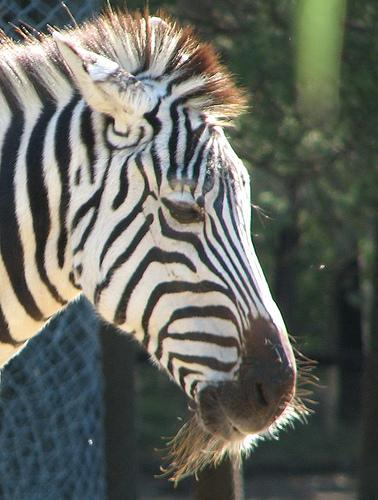What item is present in the background behind the zebra, and how detailed is it? There is a chain fence behind the zebra, but it's barely visible due to the limited coverage in the image. Elaborate on the zebra's neck detail and the orientation of its stripes. The zebra's neck has wide black and white stripes that are vertical on the front part, and the mane is sticking straight up. Discuss one particular feature related to the zebra's head and explain it in detail. The zebra has ears that are back on its head, which can suggest attentiveness or a relaxed state. What is the dominant pattern on the zebra's body and how is its mane oriented? The dominant pattern is black and white stripes, and the mane is sticking straight up. How would you describe the overall appearance of the zebra in the image, including its colors and features? The zebra has a striking appearance with its black and white striped pattern, brown nose, upright mane, and various facial features such as large nostrils, long eyelashes, and whiskers. Determine the color of zebra's nose and the appearance of the stripes on its face. The zebra's nose is brown, and the stripes on its face are black and white. Briefly describe the details of the zebra's face in the image. The zebra's face has black and white stripes, a brown nose, large nostrils, fine hairs on the muzzle, and long eyelashes. Describe the zebra's eyes and the area around them. The zebra's eyes are black, surrounded by thin black and white stripes, and they have long eyelashes. Examine the zebra's nose and mention its color and the presence of any facial hair. The zebra's nose is brown, and there are whiskers and fine hairs on its muzzle. Identify the animal in the image and list two distinct features. The animal is a zebra, and it has black and white stripes and a mane sticking straight up. 